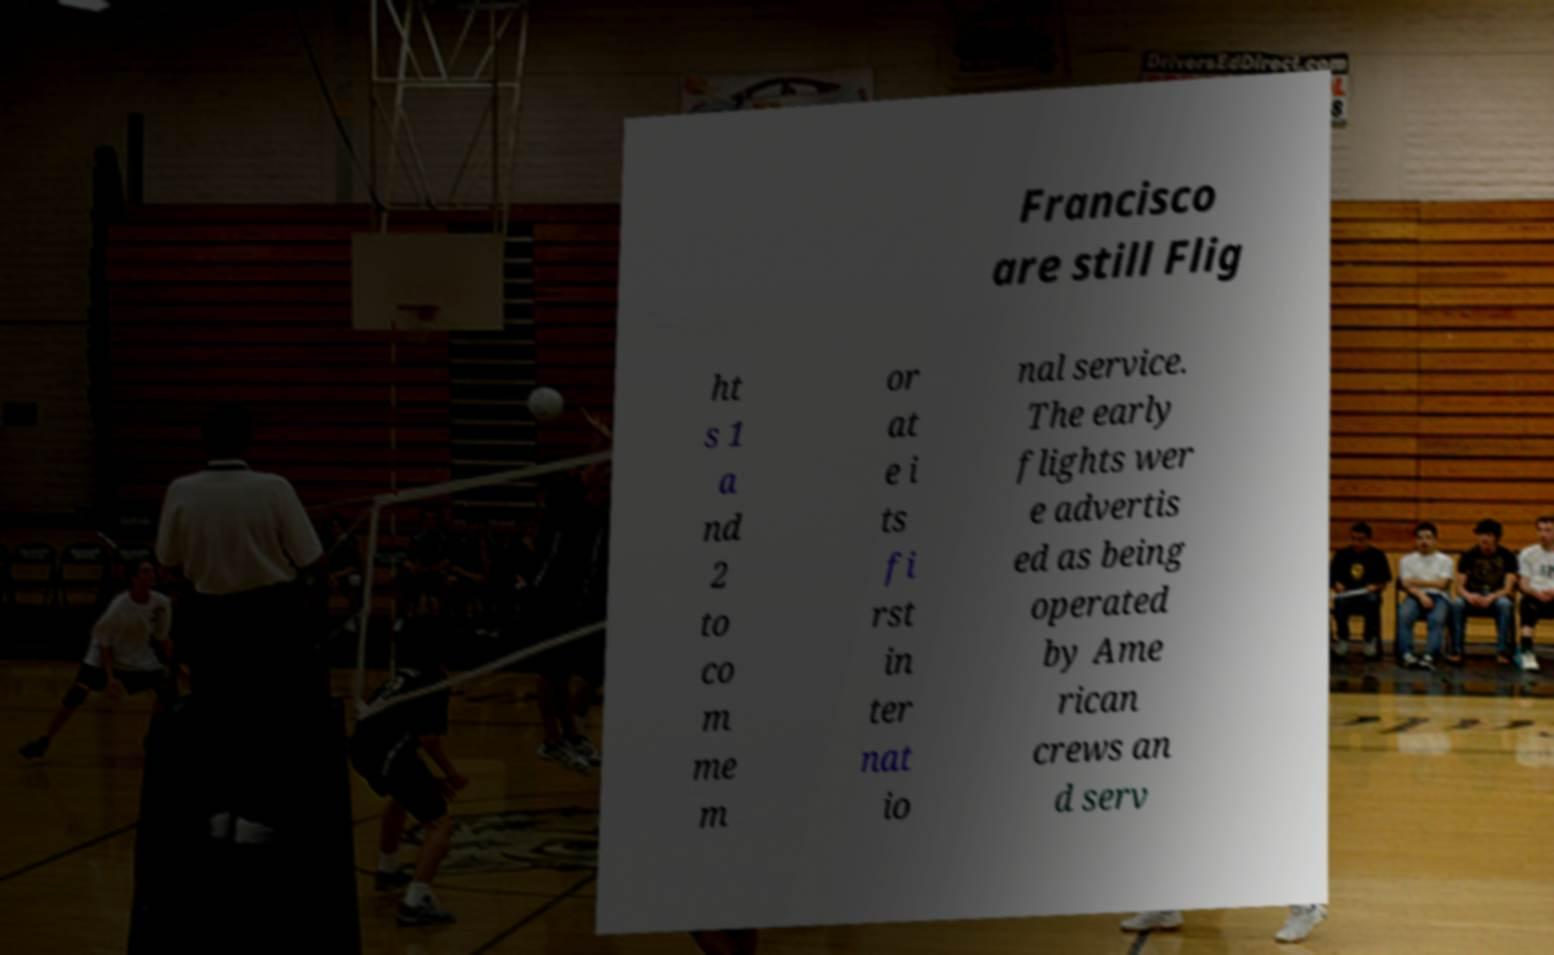I need the written content from this picture converted into text. Can you do that? Francisco are still Flig ht s 1 a nd 2 to co m me m or at e i ts fi rst in ter nat io nal service. The early flights wer e advertis ed as being operated by Ame rican crews an d serv 